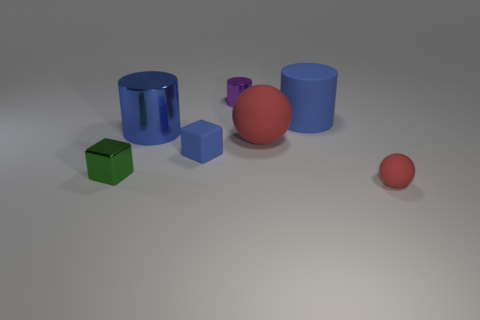What materials do the objects in the image appear to be made from? The objects in the image seem to have a matte finish and solid colors, which suggest that they could be made of a plastic or matte-painted metal material. The reflections and shadows on the surfaces give off a sense of a smooth texture that can be associated with such materials. 